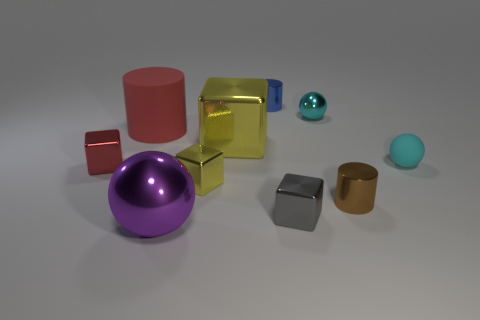Is the number of red metal cylinders greater than the number of small yellow cubes?
Your response must be concise. No. How many objects are both to the left of the big shiny sphere and behind the red block?
Provide a short and direct response. 1. There is a big thing right of the big thing that is in front of the cyan object to the right of the brown shiny cylinder; what is its shape?
Give a very brief answer. Cube. Is there anything else that is the same shape as the large rubber object?
Your answer should be compact. Yes. What number of balls are big metal objects or small yellow metallic objects?
Offer a terse response. 1. There is a cube to the left of the big metal sphere; is it the same color as the rubber cylinder?
Offer a terse response. Yes. There is a red object behind the small metal block left of the rubber object that is on the left side of the large yellow shiny cube; what is its material?
Offer a terse response. Rubber. Do the gray cube and the cyan shiny object have the same size?
Give a very brief answer. Yes. Does the big matte thing have the same color as the small block that is on the left side of the big matte object?
Your answer should be very brief. Yes. There is a large purple object that is the same material as the tiny brown thing; what shape is it?
Keep it short and to the point. Sphere. 